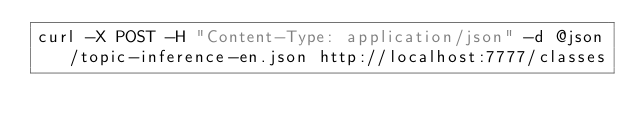Convert code to text. <code><loc_0><loc_0><loc_500><loc_500><_Bash_>curl -X POST -H "Content-Type: application/json" -d @json/topic-inference-en.json http://localhost:7777/classes</code> 